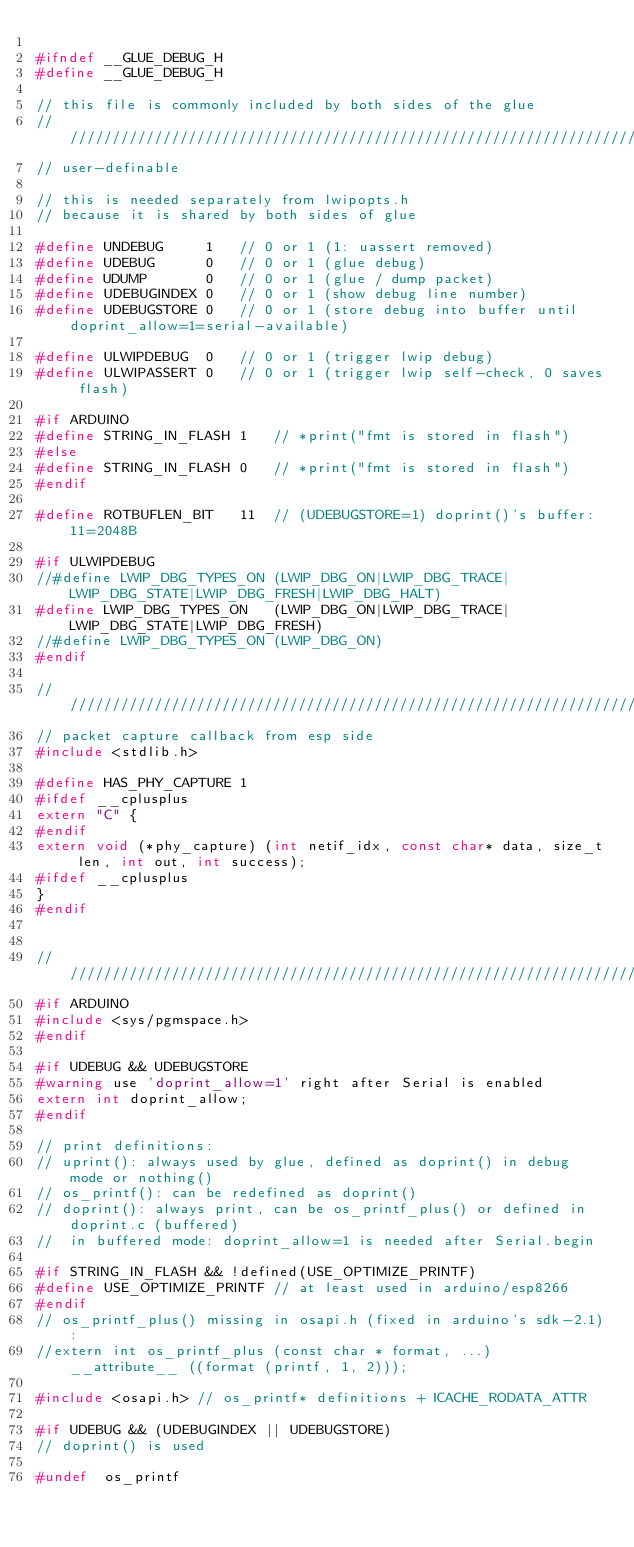Convert code to text. <code><loc_0><loc_0><loc_500><loc_500><_C_>
#ifndef __GLUE_DEBUG_H
#define __GLUE_DEBUG_H

// this file is commonly included by both sides of the glue
/////////////////////////////////////////////////////////////////////////////
// user-definable

// this is needed separately from lwipopts.h
// because it is shared by both sides of glue

#define UNDEBUG		1	// 0 or 1 (1: uassert removed)
#define UDEBUG		0	// 0 or 1 (glue debug)
#define UDUMP		0	// 0 or 1 (glue / dump packet)
#define UDEBUGINDEX	0	// 0 or 1 (show debug line number)
#define UDEBUGSTORE	0	// 0 or 1 (store debug into buffer until doprint_allow=1=serial-available)

#define ULWIPDEBUG	0	// 0 or 1 (trigger lwip debug)
#define ULWIPASSERT	0	// 0 or 1 (trigger lwip self-check, 0 saves flash)

#if ARDUINO
#define STRING_IN_FLASH 1	// *print("fmt is stored in flash")
#else
#define STRING_IN_FLASH 0	// *print("fmt is stored in flash")
#endif

#define ROTBUFLEN_BIT	11	// (UDEBUGSTORE=1) doprint()'s buffer: 11=2048B

#if ULWIPDEBUG
//#define LWIP_DBG_TYPES_ON	(LWIP_DBG_ON|LWIP_DBG_TRACE|LWIP_DBG_STATE|LWIP_DBG_FRESH|LWIP_DBG_HALT)
#define LWIP_DBG_TYPES_ON	(LWIP_DBG_ON|LWIP_DBG_TRACE|LWIP_DBG_STATE|LWIP_DBG_FRESH)
//#define LWIP_DBG_TYPES_ON	(LWIP_DBG_ON)
#endif

/////////////////////////////////////////////////////////////////////////////
// packet capture callback from esp side
#include <stdlib.h>

#define HAS_PHY_CAPTURE 1
#ifdef __cplusplus
extern "C" {
#endif
extern void (*phy_capture) (int netif_idx, const char* data, size_t len, int out, int success);
#ifdef __cplusplus
}
#endif


/////////////////////////////////////////////////////////////////////////////
#if ARDUINO
#include <sys/pgmspace.h>
#endif

#if UDEBUG && UDEBUGSTORE
#warning use 'doprint_allow=1' right after Serial is enabled
extern int doprint_allow;
#endif

// print definitions:
// uprint(): always used by glue, defined as doprint() in debug mode or nothing()
// os_printf(): can be redefined as doprint()
// doprint(): always print, can be os_printf_plus() or defined in doprint.c (buffered)
//	in buffered mode: doprint_allow=1 is needed after Serial.begin

#if STRING_IN_FLASH && !defined(USE_OPTIMIZE_PRINTF)
#define USE_OPTIMIZE_PRINTF	// at least used in arduino/esp8266
#endif
// os_printf_plus() missing in osapi.h (fixed in arduino's sdk-2.1):
//extern int os_printf_plus (const char * format, ...) __attribute__ ((format (printf, 1, 2)));

#include <osapi.h> // os_printf* definitions + ICACHE_RODATA_ATTR

#if UDEBUG && (UDEBUGINDEX || UDEBUGSTORE)
// doprint() is used

#undef	os_printf</code> 